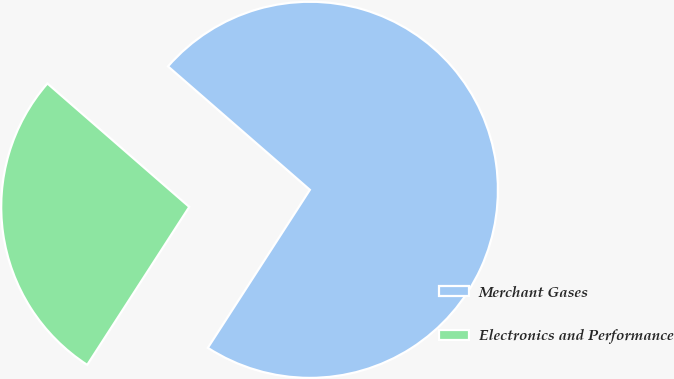Convert chart to OTSL. <chart><loc_0><loc_0><loc_500><loc_500><pie_chart><fcel>Merchant Gases<fcel>Electronics and Performance<nl><fcel>72.73%<fcel>27.27%<nl></chart> 